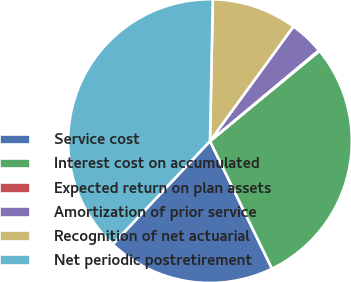Convert chart. <chart><loc_0><loc_0><loc_500><loc_500><pie_chart><fcel>Service cost<fcel>Interest cost on accumulated<fcel>Expected return on plan assets<fcel>Amortization of prior service<fcel>Recognition of net actuarial<fcel>Net periodic postretirement<nl><fcel>19.23%<fcel>28.76%<fcel>0.1%<fcel>3.92%<fcel>9.7%<fcel>38.29%<nl></chart> 